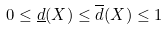Convert formula to latex. <formula><loc_0><loc_0><loc_500><loc_500>0 \leq \underline { d } ( X ) \leq \overline { d } ( X ) \leq 1</formula> 